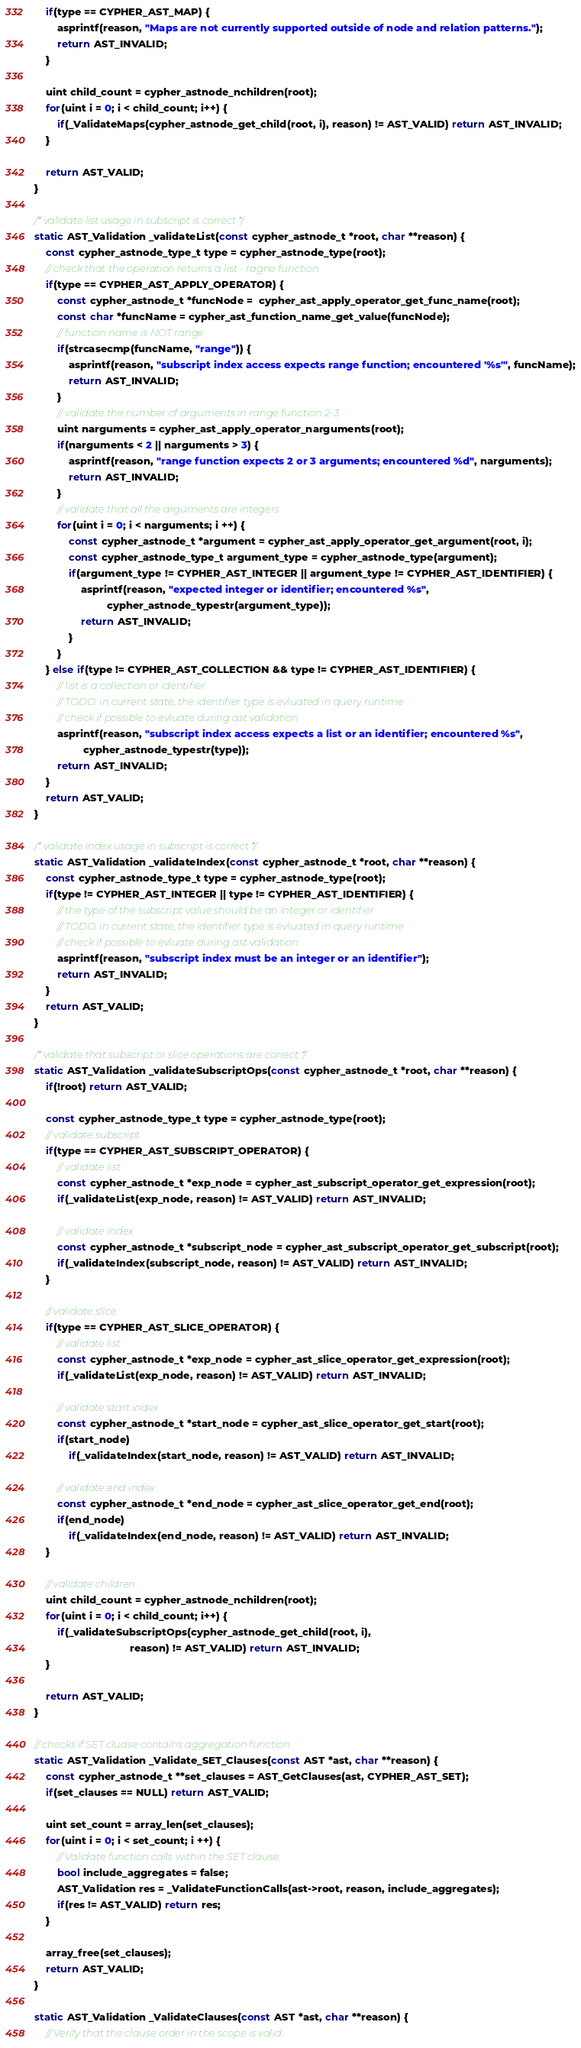Convert code to text. <code><loc_0><loc_0><loc_500><loc_500><_C_>	if(type == CYPHER_AST_MAP) {
		asprintf(reason, "Maps are not currently supported outside of node and relation patterns.");
		return AST_INVALID;
	}

	uint child_count = cypher_astnode_nchildren(root);
	for(uint i = 0; i < child_count; i++) {
		if(_ValidateMaps(cypher_astnode_get_child(root, i), reason) != AST_VALID) return AST_INVALID;
	}

	return AST_VALID;
}

/* validate list usage in subscript is correct */
static AST_Validation _validateList(const cypher_astnode_t *root, char **reason) {
	const cypher_astnode_type_t type = cypher_astnode_type(root);
	// check that the operation returns a list - ragne function
	if(type == CYPHER_AST_APPLY_OPERATOR) {
		const cypher_astnode_t *funcNode =  cypher_ast_apply_operator_get_func_name(root);
		const char *funcName = cypher_ast_function_name_get_value(funcNode);
		// function name is NOT range
		if(strcasecmp(funcName, "range")) {
			asprintf(reason, "subscript index access expects range function; encountered '%s'", funcName);
			return AST_INVALID;
		}
		// validate the number of arguments in range function 2-3
		uint narguments = cypher_ast_apply_operator_narguments(root);
		if(narguments < 2 || narguments > 3) {
			asprintf(reason, "range function expects 2 or 3 arguments; encountered %d", narguments);
			return AST_INVALID;
		}
		// validate that all the arguments are integers
		for(uint i = 0; i < narguments; i ++) {
			const cypher_astnode_t *argument = cypher_ast_apply_operator_get_argument(root, i);
			const cypher_astnode_type_t argument_type = cypher_astnode_type(argument);
			if(argument_type != CYPHER_AST_INTEGER || argument_type != CYPHER_AST_IDENTIFIER) {
				asprintf(reason, "expected integer or identifier; encountered %s",
						 cypher_astnode_typestr(argument_type));
				return AST_INVALID;
			}
		}
	} else if(type != CYPHER_AST_COLLECTION && type != CYPHER_AST_IDENTIFIER) {
		// list is a collection or identifier
		// TODO: in current state, the identifier type is evluated in query runtime
		// check if possible to evluate during ast validation
		asprintf(reason, "subscript index access expects a list or an identifier; encountered %s",
				 cypher_astnode_typestr(type));
		return AST_INVALID;
	}
	return AST_VALID;
}

/* validate index usage in subscript is correct */
static AST_Validation _validateIndex(const cypher_astnode_t *root, char **reason) {
	const cypher_astnode_type_t type = cypher_astnode_type(root);
	if(type != CYPHER_AST_INTEGER || type != CYPHER_AST_IDENTIFIER) {
		// the type of the subscript value should be an integer or identifier
		// TODO: in current state, the identifier type is evluated in query runtime
		// check if possible to evluate during ast validation
		asprintf(reason, "subscript index must be an integer or an identifier");
		return AST_INVALID;
	}
	return AST_VALID;
}

/* validate that subscript or slice operations are correct */
static AST_Validation _validateSubscriptOps(const cypher_astnode_t *root, char **reason) {
	if(!root) return AST_VALID;

	const cypher_astnode_type_t type = cypher_astnode_type(root);
	// validate subscript
	if(type == CYPHER_AST_SUBSCRIPT_OPERATOR) {
		// validate list
		const cypher_astnode_t *exp_node = cypher_ast_subscript_operator_get_expression(root);
		if(_validateList(exp_node, reason) != AST_VALID) return AST_INVALID;

		// validate index
		const cypher_astnode_t *subscript_node = cypher_ast_subscript_operator_get_subscript(root);
		if(_validateIndex(subscript_node, reason) != AST_VALID) return AST_INVALID;
	}

	// validate slice
	if(type == CYPHER_AST_SLICE_OPERATOR) {
		// validate list
		const cypher_astnode_t *exp_node = cypher_ast_slice_operator_get_expression(root);
		if(_validateList(exp_node, reason) != AST_VALID) return AST_INVALID;

		// validate start index
		const cypher_astnode_t *start_node = cypher_ast_slice_operator_get_start(root);
		if(start_node)
			if(_validateIndex(start_node, reason) != AST_VALID) return AST_INVALID;

		// validate end index
		const cypher_astnode_t *end_node = cypher_ast_slice_operator_get_end(root);
		if(end_node)
			if(_validateIndex(end_node, reason) != AST_VALID) return AST_INVALID;
	}

	// validate children
	uint child_count = cypher_astnode_nchildren(root);
	for(uint i = 0; i < child_count; i++) {
		if(_validateSubscriptOps(cypher_astnode_get_child(root, i),
								 reason) != AST_VALID) return AST_INVALID;
	}

	return AST_VALID;
}

// checks if SET cluase contains aggregation function
static AST_Validation _Validate_SET_Clauses(const AST *ast, char **reason) {
	const cypher_astnode_t **set_clauses = AST_GetClauses(ast, CYPHER_AST_SET);
	if(set_clauses == NULL) return AST_VALID;

	uint set_count = array_len(set_clauses);
	for(uint i = 0; i < set_count; i ++) {
		// Validate function calls within the SET clause.
		bool include_aggregates = false;
		AST_Validation res = _ValidateFunctionCalls(ast->root, reason, include_aggregates);
		if(res != AST_VALID) return res;
	}

	array_free(set_clauses);
	return AST_VALID;
}

static AST_Validation _ValidateClauses(const AST *ast, char **reason) {
	// Verify that the clause order in the scope is valid.</code> 